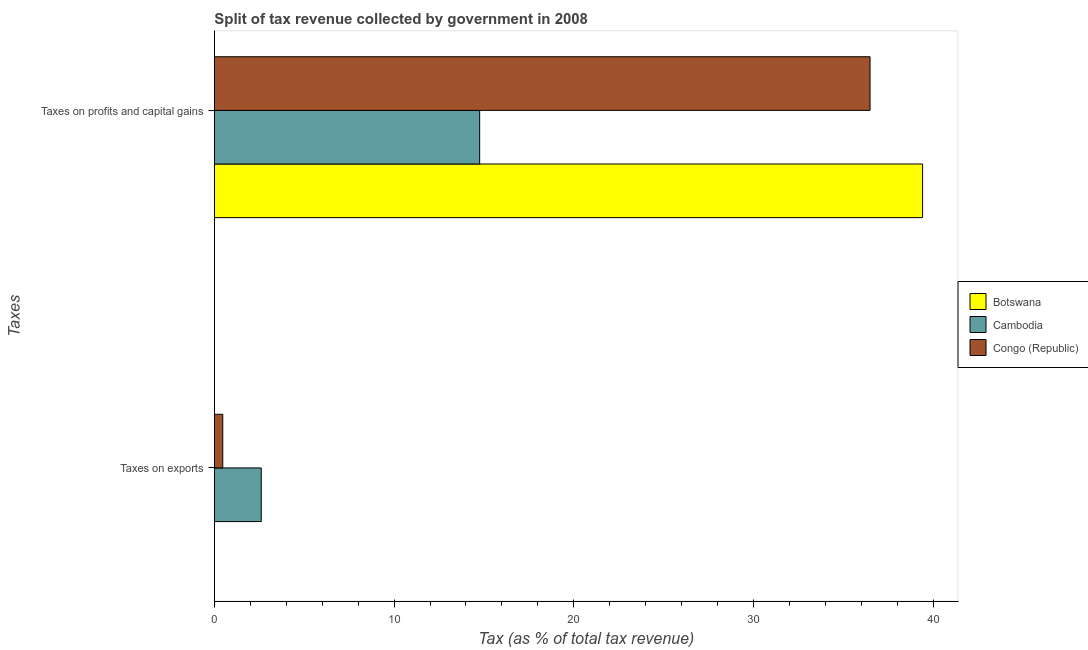How many groups of bars are there?
Offer a very short reply. 2. Are the number of bars per tick equal to the number of legend labels?
Provide a succinct answer. Yes. Are the number of bars on each tick of the Y-axis equal?
Your response must be concise. Yes. How many bars are there on the 2nd tick from the bottom?
Your response must be concise. 3. What is the label of the 2nd group of bars from the top?
Offer a very short reply. Taxes on exports. What is the percentage of revenue obtained from taxes on exports in Botswana?
Make the answer very short. 0.01. Across all countries, what is the maximum percentage of revenue obtained from taxes on exports?
Your response must be concise. 2.61. Across all countries, what is the minimum percentage of revenue obtained from taxes on exports?
Provide a short and direct response. 0.01. In which country was the percentage of revenue obtained from taxes on profits and capital gains maximum?
Keep it short and to the point. Botswana. In which country was the percentage of revenue obtained from taxes on profits and capital gains minimum?
Ensure brevity in your answer.  Cambodia. What is the total percentage of revenue obtained from taxes on profits and capital gains in the graph?
Your response must be concise. 90.64. What is the difference between the percentage of revenue obtained from taxes on profits and capital gains in Cambodia and that in Congo (Republic)?
Ensure brevity in your answer.  -21.72. What is the difference between the percentage of revenue obtained from taxes on profits and capital gains in Cambodia and the percentage of revenue obtained from taxes on exports in Botswana?
Your response must be concise. 14.75. What is the average percentage of revenue obtained from taxes on profits and capital gains per country?
Keep it short and to the point. 30.21. What is the difference between the percentage of revenue obtained from taxes on exports and percentage of revenue obtained from taxes on profits and capital gains in Cambodia?
Offer a very short reply. -12.15. What is the ratio of the percentage of revenue obtained from taxes on exports in Botswana to that in Congo (Republic)?
Make the answer very short. 0.02. Is the percentage of revenue obtained from taxes on exports in Botswana less than that in Congo (Republic)?
Provide a short and direct response. Yes. In how many countries, is the percentage of revenue obtained from taxes on profits and capital gains greater than the average percentage of revenue obtained from taxes on profits and capital gains taken over all countries?
Provide a short and direct response. 2. What does the 2nd bar from the top in Taxes on profits and capital gains represents?
Your response must be concise. Cambodia. What does the 1st bar from the bottom in Taxes on profits and capital gains represents?
Provide a short and direct response. Botswana. How many bars are there?
Ensure brevity in your answer.  6. How many countries are there in the graph?
Offer a terse response. 3. Does the graph contain any zero values?
Provide a short and direct response. No. Where does the legend appear in the graph?
Offer a terse response. Center right. How are the legend labels stacked?
Provide a short and direct response. Vertical. What is the title of the graph?
Make the answer very short. Split of tax revenue collected by government in 2008. Does "Swaziland" appear as one of the legend labels in the graph?
Provide a short and direct response. No. What is the label or title of the X-axis?
Your response must be concise. Tax (as % of total tax revenue). What is the label or title of the Y-axis?
Offer a very short reply. Taxes. What is the Tax (as % of total tax revenue) in Botswana in Taxes on exports?
Give a very brief answer. 0.01. What is the Tax (as % of total tax revenue) of Cambodia in Taxes on exports?
Offer a very short reply. 2.61. What is the Tax (as % of total tax revenue) in Congo (Republic) in Taxes on exports?
Provide a short and direct response. 0.47. What is the Tax (as % of total tax revenue) of Botswana in Taxes on profits and capital gains?
Provide a succinct answer. 39.4. What is the Tax (as % of total tax revenue) in Cambodia in Taxes on profits and capital gains?
Offer a terse response. 14.76. What is the Tax (as % of total tax revenue) in Congo (Republic) in Taxes on profits and capital gains?
Provide a short and direct response. 36.48. Across all Taxes, what is the maximum Tax (as % of total tax revenue) of Botswana?
Provide a succinct answer. 39.4. Across all Taxes, what is the maximum Tax (as % of total tax revenue) in Cambodia?
Your response must be concise. 14.76. Across all Taxes, what is the maximum Tax (as % of total tax revenue) in Congo (Republic)?
Provide a short and direct response. 36.48. Across all Taxes, what is the minimum Tax (as % of total tax revenue) in Botswana?
Provide a short and direct response. 0.01. Across all Taxes, what is the minimum Tax (as % of total tax revenue) in Cambodia?
Provide a succinct answer. 2.61. Across all Taxes, what is the minimum Tax (as % of total tax revenue) in Congo (Republic)?
Provide a succinct answer. 0.47. What is the total Tax (as % of total tax revenue) of Botswana in the graph?
Ensure brevity in your answer.  39.41. What is the total Tax (as % of total tax revenue) of Cambodia in the graph?
Your answer should be very brief. 17.37. What is the total Tax (as % of total tax revenue) of Congo (Republic) in the graph?
Ensure brevity in your answer.  36.95. What is the difference between the Tax (as % of total tax revenue) of Botswana in Taxes on exports and that in Taxes on profits and capital gains?
Make the answer very short. -39.4. What is the difference between the Tax (as % of total tax revenue) in Cambodia in Taxes on exports and that in Taxes on profits and capital gains?
Keep it short and to the point. -12.15. What is the difference between the Tax (as % of total tax revenue) of Congo (Republic) in Taxes on exports and that in Taxes on profits and capital gains?
Keep it short and to the point. -36.01. What is the difference between the Tax (as % of total tax revenue) of Botswana in Taxes on exports and the Tax (as % of total tax revenue) of Cambodia in Taxes on profits and capital gains?
Offer a terse response. -14.75. What is the difference between the Tax (as % of total tax revenue) in Botswana in Taxes on exports and the Tax (as % of total tax revenue) in Congo (Republic) in Taxes on profits and capital gains?
Provide a short and direct response. -36.47. What is the difference between the Tax (as % of total tax revenue) of Cambodia in Taxes on exports and the Tax (as % of total tax revenue) of Congo (Republic) in Taxes on profits and capital gains?
Your answer should be compact. -33.87. What is the average Tax (as % of total tax revenue) in Botswana per Taxes?
Make the answer very short. 19.71. What is the average Tax (as % of total tax revenue) in Cambodia per Taxes?
Your response must be concise. 8.69. What is the average Tax (as % of total tax revenue) of Congo (Republic) per Taxes?
Your response must be concise. 18.47. What is the difference between the Tax (as % of total tax revenue) of Botswana and Tax (as % of total tax revenue) of Cambodia in Taxes on exports?
Your answer should be very brief. -2.6. What is the difference between the Tax (as % of total tax revenue) in Botswana and Tax (as % of total tax revenue) in Congo (Republic) in Taxes on exports?
Offer a terse response. -0.46. What is the difference between the Tax (as % of total tax revenue) of Cambodia and Tax (as % of total tax revenue) of Congo (Republic) in Taxes on exports?
Keep it short and to the point. 2.14. What is the difference between the Tax (as % of total tax revenue) of Botswana and Tax (as % of total tax revenue) of Cambodia in Taxes on profits and capital gains?
Your answer should be very brief. 24.64. What is the difference between the Tax (as % of total tax revenue) in Botswana and Tax (as % of total tax revenue) in Congo (Republic) in Taxes on profits and capital gains?
Provide a succinct answer. 2.92. What is the difference between the Tax (as % of total tax revenue) in Cambodia and Tax (as % of total tax revenue) in Congo (Republic) in Taxes on profits and capital gains?
Offer a very short reply. -21.72. What is the ratio of the Tax (as % of total tax revenue) in Cambodia in Taxes on exports to that in Taxes on profits and capital gains?
Offer a terse response. 0.18. What is the ratio of the Tax (as % of total tax revenue) of Congo (Republic) in Taxes on exports to that in Taxes on profits and capital gains?
Ensure brevity in your answer.  0.01. What is the difference between the highest and the second highest Tax (as % of total tax revenue) in Botswana?
Make the answer very short. 39.4. What is the difference between the highest and the second highest Tax (as % of total tax revenue) in Cambodia?
Give a very brief answer. 12.15. What is the difference between the highest and the second highest Tax (as % of total tax revenue) in Congo (Republic)?
Keep it short and to the point. 36.01. What is the difference between the highest and the lowest Tax (as % of total tax revenue) in Botswana?
Your response must be concise. 39.4. What is the difference between the highest and the lowest Tax (as % of total tax revenue) of Cambodia?
Your answer should be very brief. 12.15. What is the difference between the highest and the lowest Tax (as % of total tax revenue) in Congo (Republic)?
Offer a terse response. 36.01. 